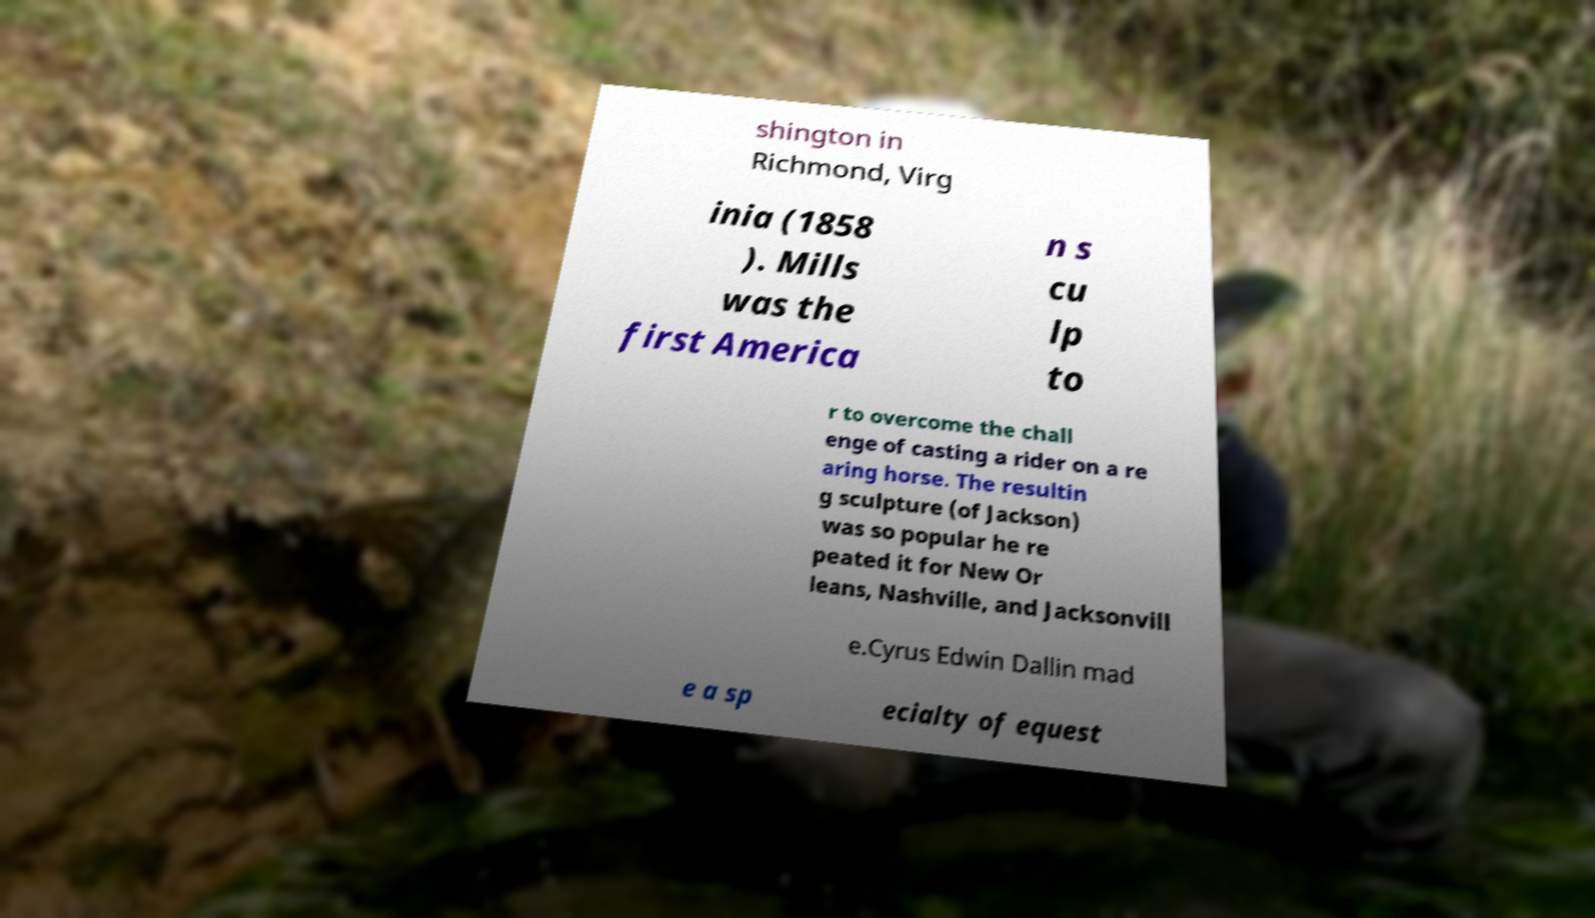For documentation purposes, I need the text within this image transcribed. Could you provide that? shington in Richmond, Virg inia (1858 ). Mills was the first America n s cu lp to r to overcome the chall enge of casting a rider on a re aring horse. The resultin g sculpture (of Jackson) was so popular he re peated it for New Or leans, Nashville, and Jacksonvill e.Cyrus Edwin Dallin mad e a sp ecialty of equest 